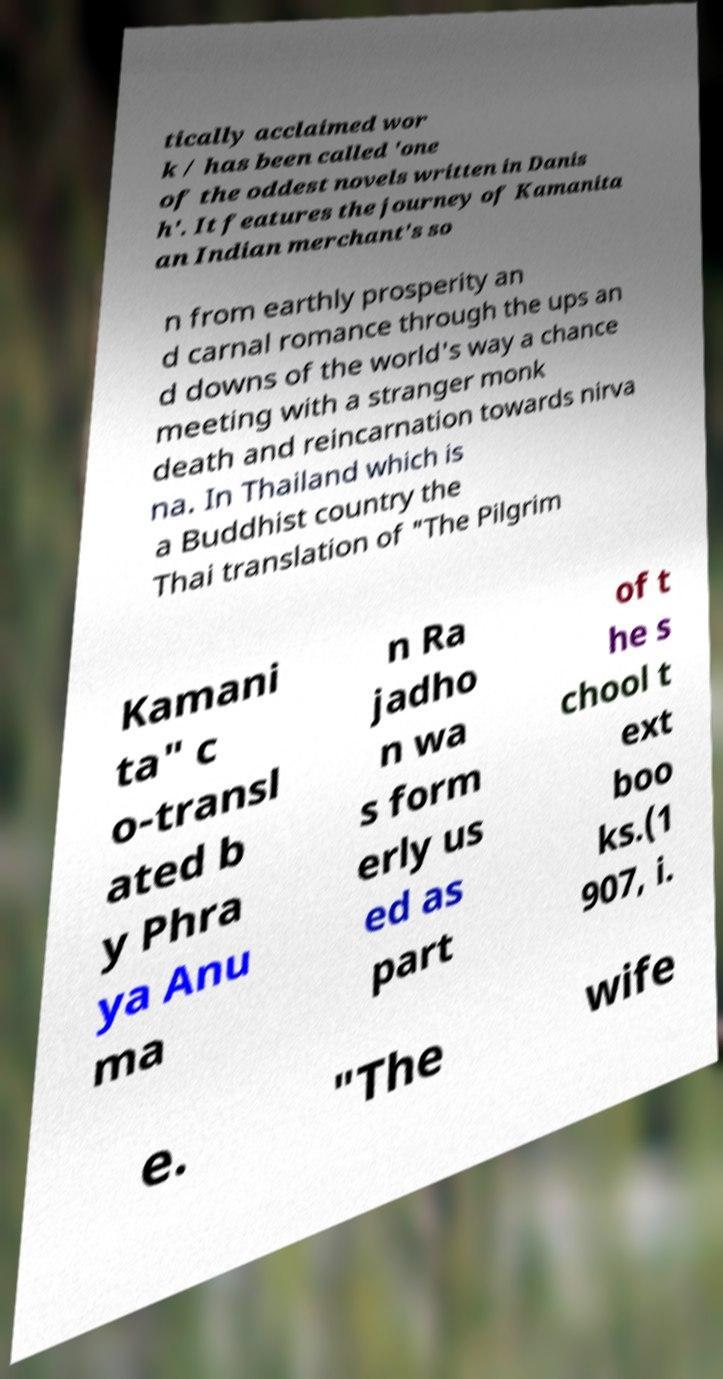Please identify and transcribe the text found in this image. tically acclaimed wor k / has been called 'one of the oddest novels written in Danis h'. It features the journey of Kamanita an Indian merchant's so n from earthly prosperity an d carnal romance through the ups an d downs of the world's way a chance meeting with a stranger monk death and reincarnation towards nirva na. In Thailand which is a Buddhist country the Thai translation of "The Pilgrim Kamani ta" c o-transl ated b y Phra ya Anu ma n Ra jadho n wa s form erly us ed as part of t he s chool t ext boo ks.(1 907, i. e. "The wife 